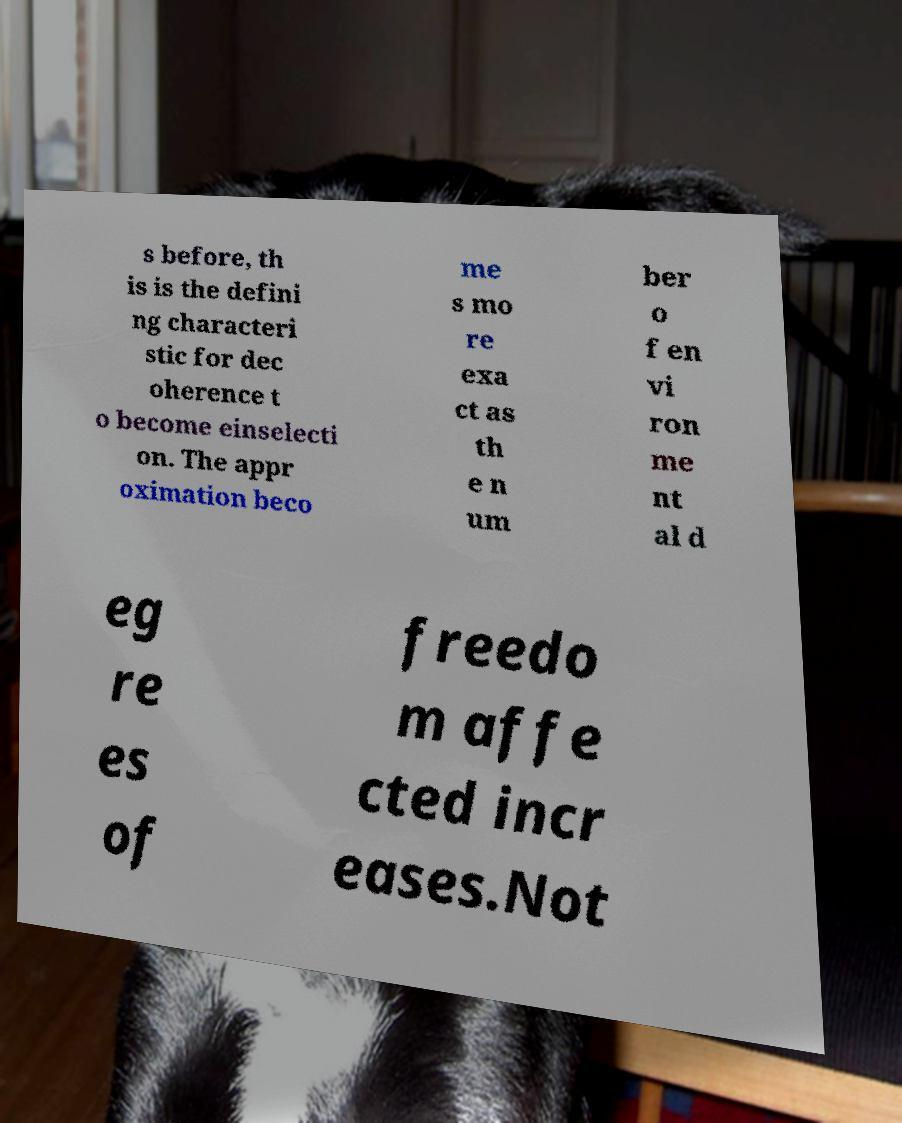Can you read and provide the text displayed in the image?This photo seems to have some interesting text. Can you extract and type it out for me? s before, th is is the defini ng characteri stic for dec oherence t o become einselecti on. The appr oximation beco me s mo re exa ct as th e n um ber o f en vi ron me nt al d eg re es of freedo m affe cted incr eases.Not 